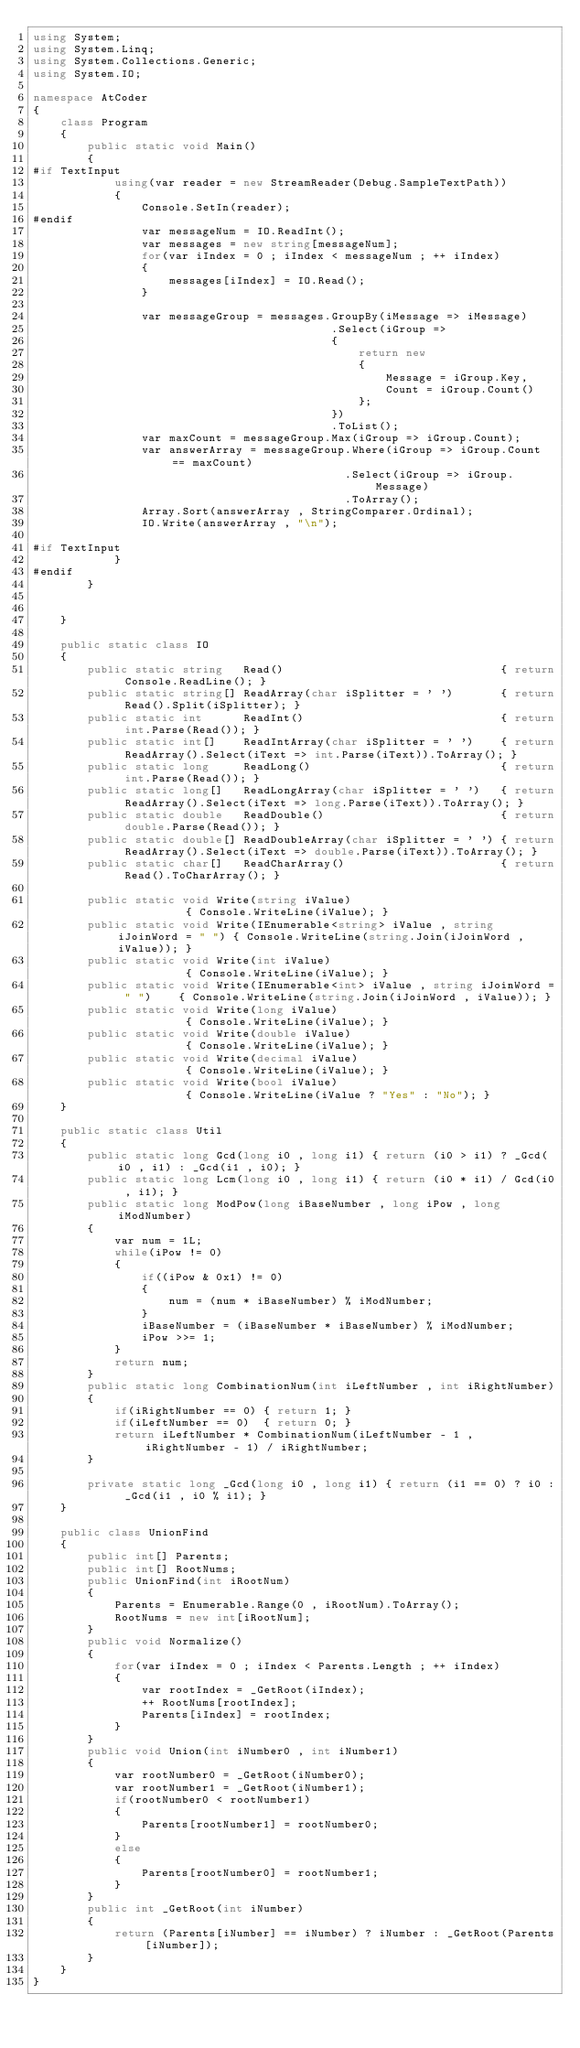<code> <loc_0><loc_0><loc_500><loc_500><_C#_>using System;
using System.Linq;
using System.Collections.Generic;
using System.IO;

namespace AtCoder
{
	class Program
	{
		public static void Main()
		{
#if TextInput
			using(var reader = new StreamReader(Debug.SampleTextPath)) 
			{
				Console.SetIn(reader);
#endif
				var messageNum = IO.ReadInt();
				var messages = new string[messageNum];
				for(var iIndex = 0 ; iIndex < messageNum ; ++ iIndex)
				{
					messages[iIndex] = IO.Read();
				}

				var messageGroup = messages.GroupBy(iMessage => iMessage)
											.Select(iGroup =>
											{
												return new
												{
													Message = iGroup.Key,
													Count = iGroup.Count()
												};
											})
											.ToList();
				var maxCount = messageGroup.Max(iGroup => iGroup.Count);
				var answerArray = messageGroup.Where(iGroup => iGroup.Count == maxCount)
											  .Select(iGroup => iGroup.Message)
											  .ToArray();
				Array.Sort(answerArray , StringComparer.Ordinal);
				IO.Write(answerArray , "\n");
				
#if TextInput
			}
#endif
		}

		
	}

	public static class IO
	{
		public static string   Read()								 { return Console.ReadLine(); }
		public static string[] ReadArray(char iSplitter = ' ')		 { return Read().Split(iSplitter); }
		public static int	   ReadInt()							 { return int.Parse(Read()); }
		public static int[]	   ReadIntArray(char iSplitter = ' ')	 { return ReadArray().Select(iText => int.Parse(iText)).ToArray(); }
		public static long	   ReadLong()							 { return int.Parse(Read()); }
		public static long[]   ReadLongArray(char iSplitter = ' ')	 { return ReadArray().Select(iText => long.Parse(iText)).ToArray(); }
		public static double   ReadDouble()							 { return double.Parse(Read()); }
		public static double[] ReadDoubleArray(char iSplitter = ' ') { return ReadArray().Select(iText => double.Parse(iText)).ToArray(); }
		public static char[]   ReadCharArray()						 { return Read().ToCharArray(); }

		public static void Write(string iValue)										  { Console.WriteLine(iValue); }
		public static void Write(IEnumerable<string> iValue , string iJoinWord = " ") { Console.WriteLine(string.Join(iJoinWord , iValue)); }
		public static void Write(int iValue)										  { Console.WriteLine(iValue); }
		public static void Write(IEnumerable<int> iValue , string iJoinWord = " ")	  { Console.WriteLine(string.Join(iJoinWord , iValue)); }
		public static void Write(long iValue)										  { Console.WriteLine(iValue); }
		public static void Write(double iValue)										  { Console.WriteLine(iValue); }
		public static void Write(decimal iValue)									  { Console.WriteLine(iValue); }
		public static void Write(bool iValue)										  { Console.WriteLine(iValue ? "Yes" : "No"); }
	}

	public static class Util
	{
		public static long Gcd(long i0 , long i1) { return (i0 > i1) ? _Gcd(i0 , i1) : _Gcd(i1 , i0); }
		public static long Lcm(long i0 , long i1) { return (i0 * i1) / Gcd(i0 , i1); }
		public static long ModPow(long iBaseNumber , long iPow , long iModNumber)
		{
			var num = 1L;
			while(iPow != 0)
			{
				if((iPow & 0x1) != 0)
				{
					num = (num * iBaseNumber) % iModNumber;
				}
				iBaseNumber = (iBaseNumber * iBaseNumber) % iModNumber;
				iPow >>= 1;
			}
			return num;
		}
		public static long CombinationNum(int iLeftNumber , int iRightNumber)
		{
			if(iRightNumber == 0) { return 1; }
			if(iLeftNumber == 0)  { return 0; }
			return iLeftNumber * CombinationNum(iLeftNumber - 1 , iRightNumber - 1) / iRightNumber;
		}

		private static long _Gcd(long i0 , long i1)	{ return (i1 == 0) ? i0 : _Gcd(i1 , i0 % i1); }
	}

	public class UnionFind
	{
		public int[] Parents;
		public int[] RootNums;
		public UnionFind(int iRootNum)
		{
			Parents = Enumerable.Range(0 , iRootNum).ToArray();
			RootNums = new int[iRootNum];
		}
		public void Normalize()
		{
			for(var iIndex = 0 ; iIndex < Parents.Length ; ++ iIndex)
			{
				var rootIndex = _GetRoot(iIndex);
				++ RootNums[rootIndex];
				Parents[iIndex] = rootIndex;
			}
		}
		public void Union(int iNumber0 , int iNumber1)
		{
			var rootNumber0 = _GetRoot(iNumber0);
			var rootNumber1 = _GetRoot(iNumber1);
			if(rootNumber0 < rootNumber1)
			{
				Parents[rootNumber1] = rootNumber0;
			}
			else
			{
				Parents[rootNumber0] = rootNumber1;
			}
		}
		public int _GetRoot(int iNumber)
		{
			return (Parents[iNumber] == iNumber) ? iNumber : _GetRoot(Parents[iNumber]);
		}
	}
}
</code> 